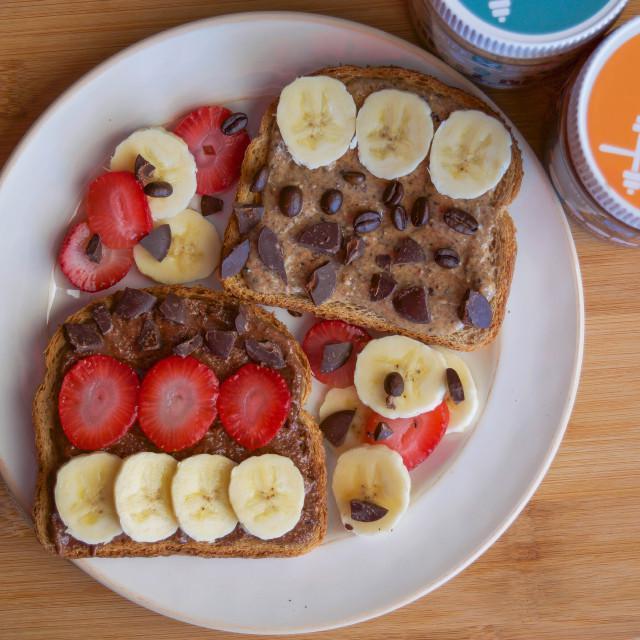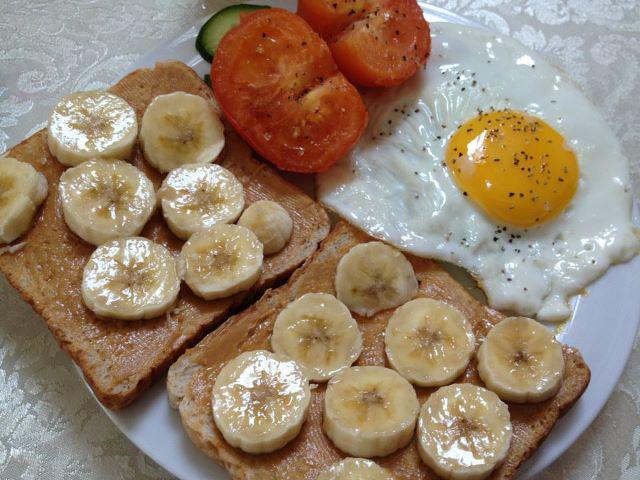The first image is the image on the left, the second image is the image on the right. Considering the images on both sides, is "There are at least five pieces of bread with pieces of banana on them." valid? Answer yes or no. No. The first image is the image on the left, the second image is the image on the right. Considering the images on both sides, is "Twenty one or fewer banana slices are visible." valid? Answer yes or no. No. 